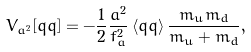Convert formula to latex. <formula><loc_0><loc_0><loc_500><loc_500>V _ { a ^ { 2 } } [ \bar { q } q ] = - \frac { 1 } { 2 } \frac { a ^ { 2 } } { f _ { a } ^ { 2 } } \, \langle \bar { q } q \rangle \, \frac { m _ { u } m _ { d } } { m _ { u } + m _ { d } } ,</formula> 